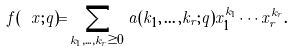Convert formula to latex. <formula><loc_0><loc_0><loc_500><loc_500>f ( \ x ; q ) = \sum _ { k _ { 1 } , \dots , k _ { r } \geq 0 } a ( k _ { 1 } , \dots , k _ { r } ; q ) x _ { 1 } ^ { k _ { 1 } } \cdots x _ { r } ^ { k _ { r } } .</formula> 